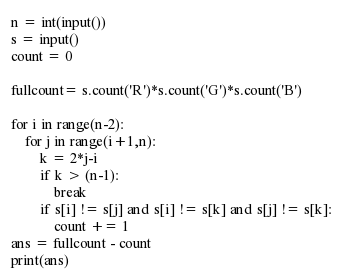Convert code to text. <code><loc_0><loc_0><loc_500><loc_500><_Python_>n = int(input())
s = input()
count = 0

fullcount= s.count('R')*s.count('G')*s.count('B')

for i in range(n-2):
    for j in range(i+1,n):
        k = 2*j-i
        if k > (n-1):
            break
        if s[i] != s[j] and s[i] != s[k] and s[j] != s[k]:
            count += 1
ans = fullcount - count
print(ans)</code> 